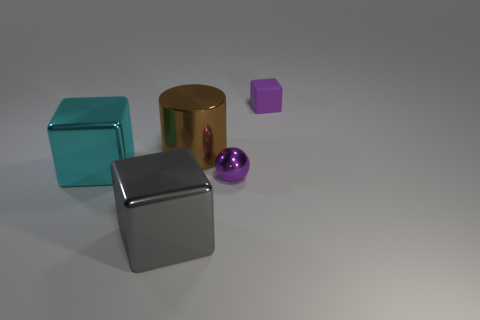There is another small thing that is the same color as the rubber thing; what is it made of?
Your response must be concise. Metal. Do the small matte block and the small metallic sphere have the same color?
Give a very brief answer. Yes. Is there a gray metallic cube of the same size as the cyan metallic block?
Provide a short and direct response. Yes. Is the color of the tiny thing that is in front of the tiny purple block the same as the rubber object?
Give a very brief answer. Yes. What number of yellow objects are shiny blocks or small metal cylinders?
Your response must be concise. 0. How many matte objects have the same color as the metal cylinder?
Offer a terse response. 0. Are the ball and the gray block made of the same material?
Keep it short and to the point. Yes. What number of cyan metal objects are behind the object on the left side of the gray block?
Give a very brief answer. 0. Is the cyan shiny thing the same size as the purple shiny sphere?
Your answer should be very brief. No. What number of other small balls are the same material as the purple ball?
Provide a short and direct response. 0. 